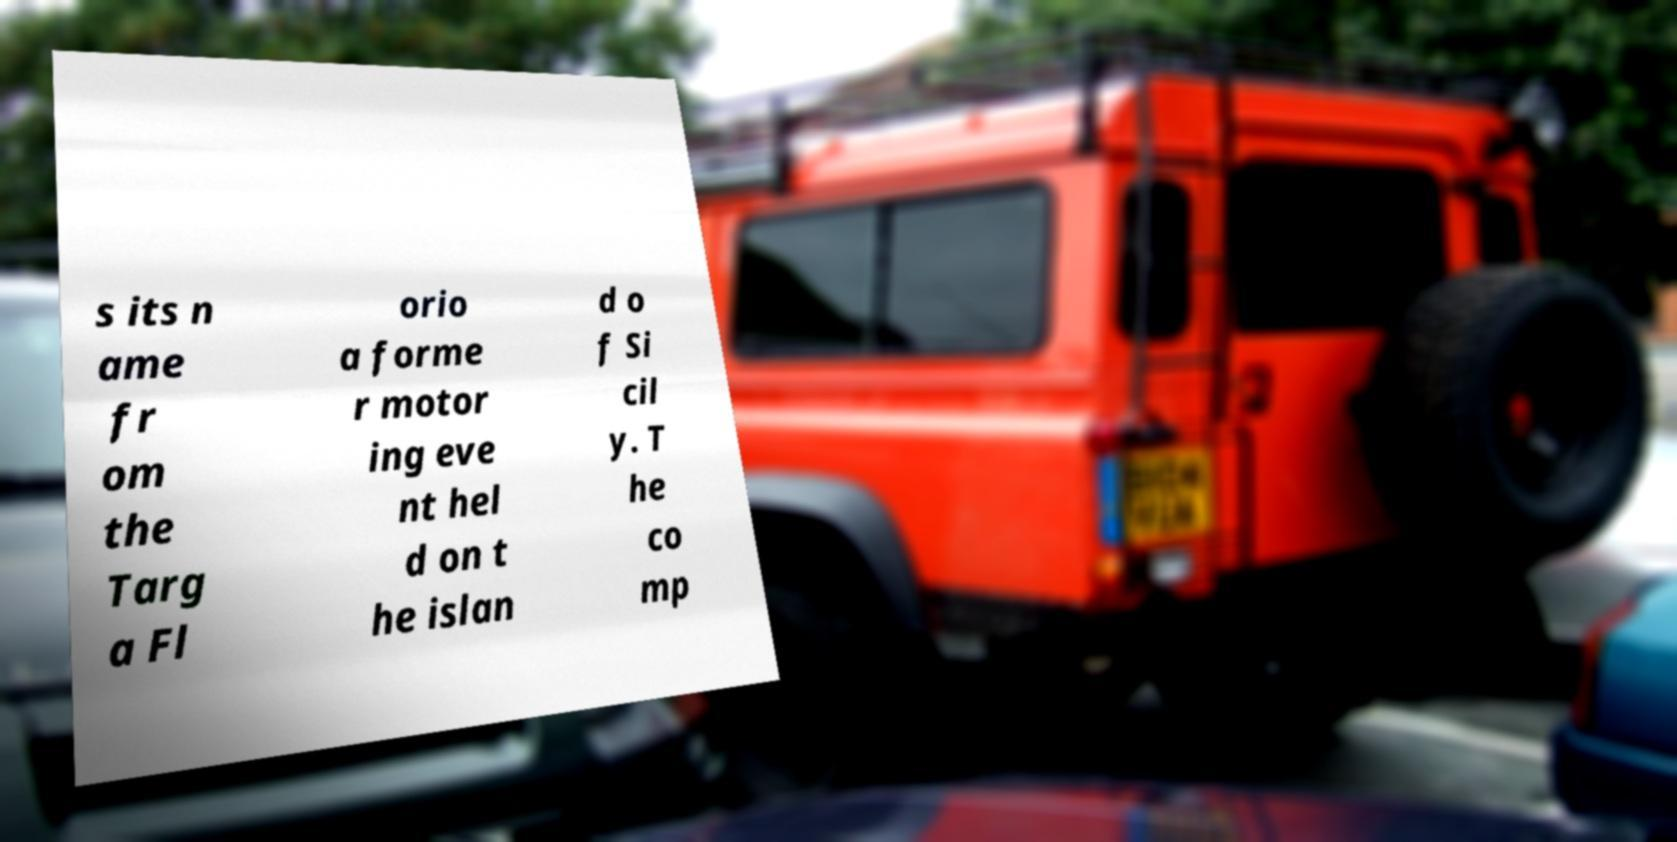Can you accurately transcribe the text from the provided image for me? s its n ame fr om the Targ a Fl orio a forme r motor ing eve nt hel d on t he islan d o f Si cil y. T he co mp 